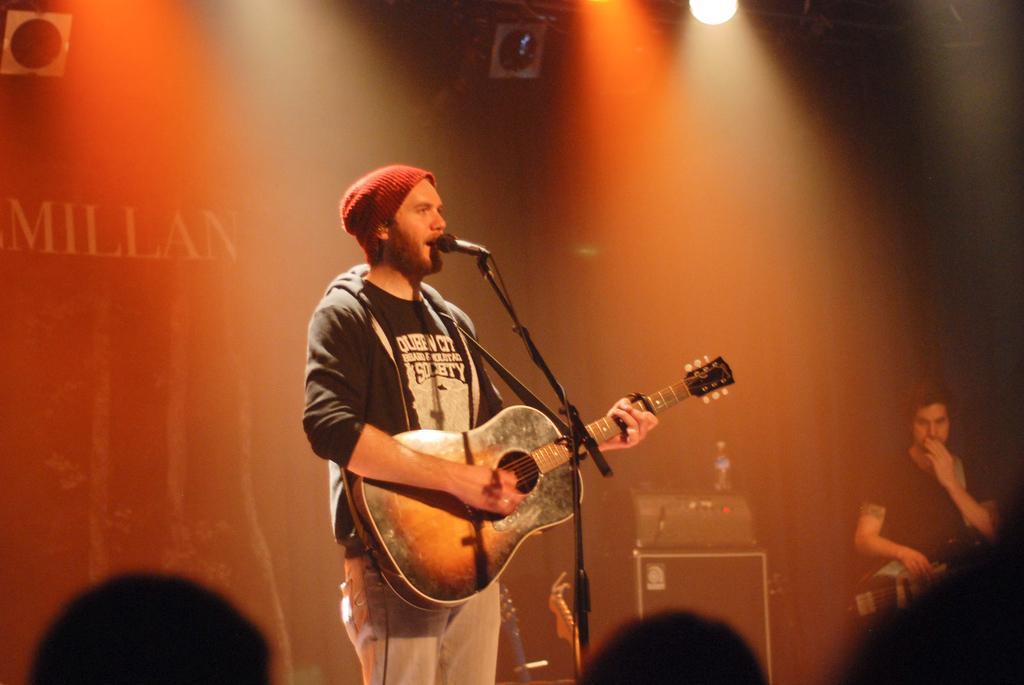Please provide a concise description of this image. This person standing and holding guitar and singing. There is a microphone with stand. We can see electrical device and bottle on the table. There is a person holding musical instrument. These are audience. On the background we can see focusing light. 